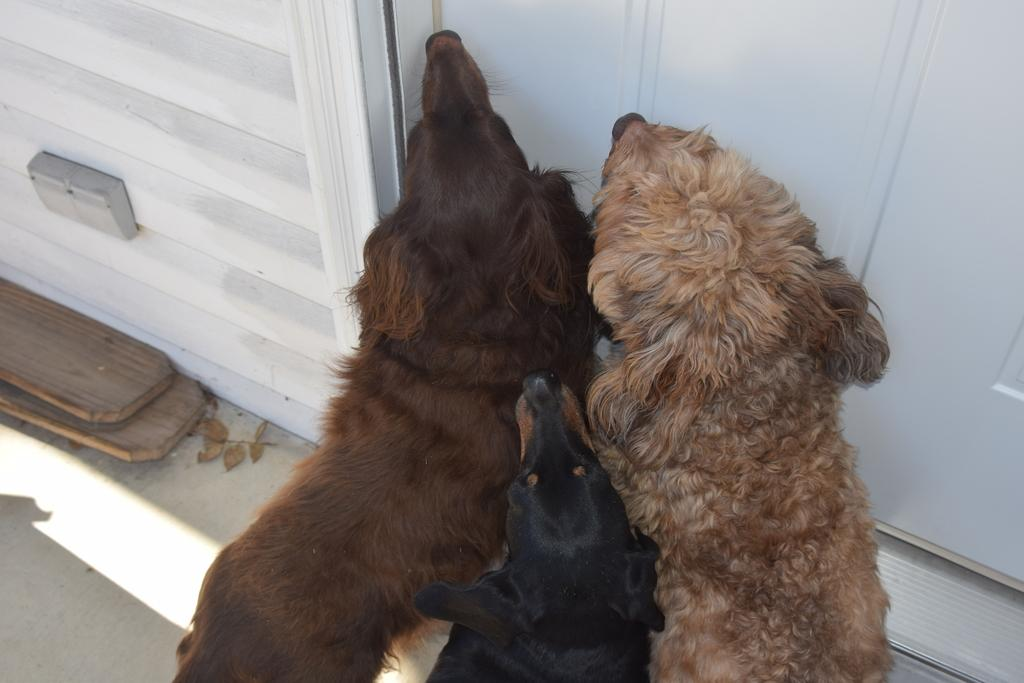What animals are in the center of the image? There are dogs in the center of the image. What is behind the dogs in the image? The dogs are in front of a door. What can be seen on the left side of the image? There are wooden sticks on the left side of the image. What type of addition problem can be solved using the wooden sticks in the image? There is no addition problem or mathematical reference in the image, as it features dogs in front of a door and wooden sticks. 